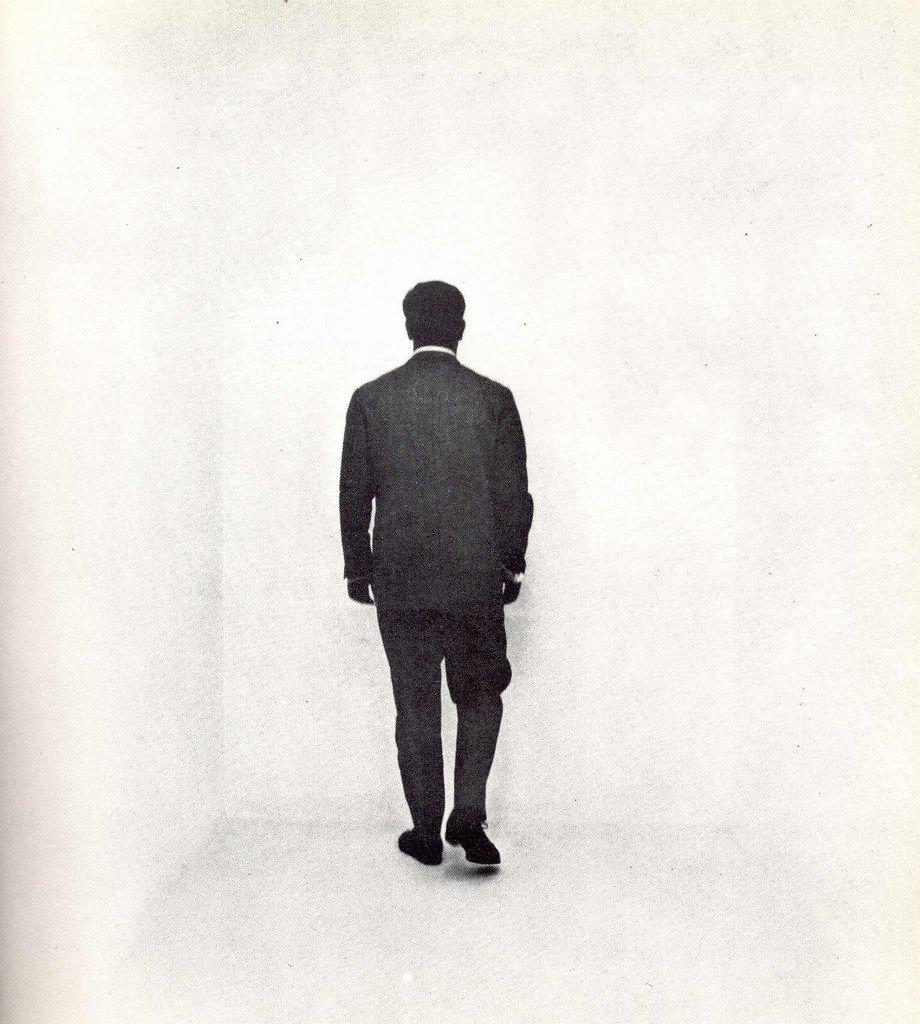Who is the main subject in the image? There is a man in the image. Where is the man located in the image? The man is in the center of the image. Which direction is the man facing in the image? The man is facing towards the background area of the image. What is the man's father doing in the background of the image? There is no information about the man's father in the image, nor is there any indication of a person in the background. 